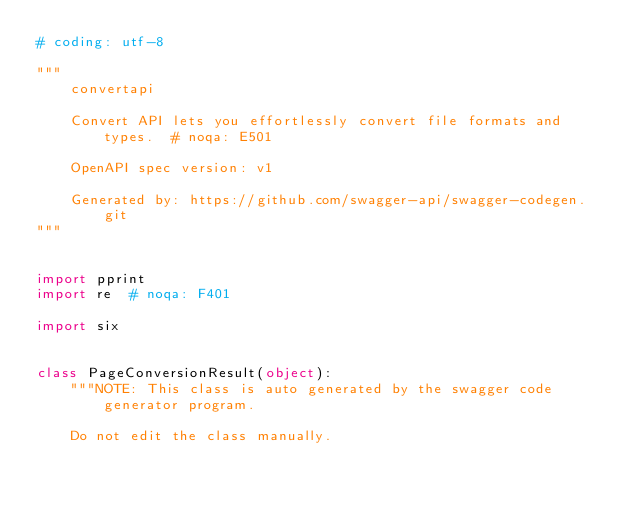<code> <loc_0><loc_0><loc_500><loc_500><_Python_># coding: utf-8

"""
    convertapi

    Convert API lets you effortlessly convert file formats and types.  # noqa: E501

    OpenAPI spec version: v1
    
    Generated by: https://github.com/swagger-api/swagger-codegen.git
"""


import pprint
import re  # noqa: F401

import six


class PageConversionResult(object):
    """NOTE: This class is auto generated by the swagger code generator program.

    Do not edit the class manually.</code> 